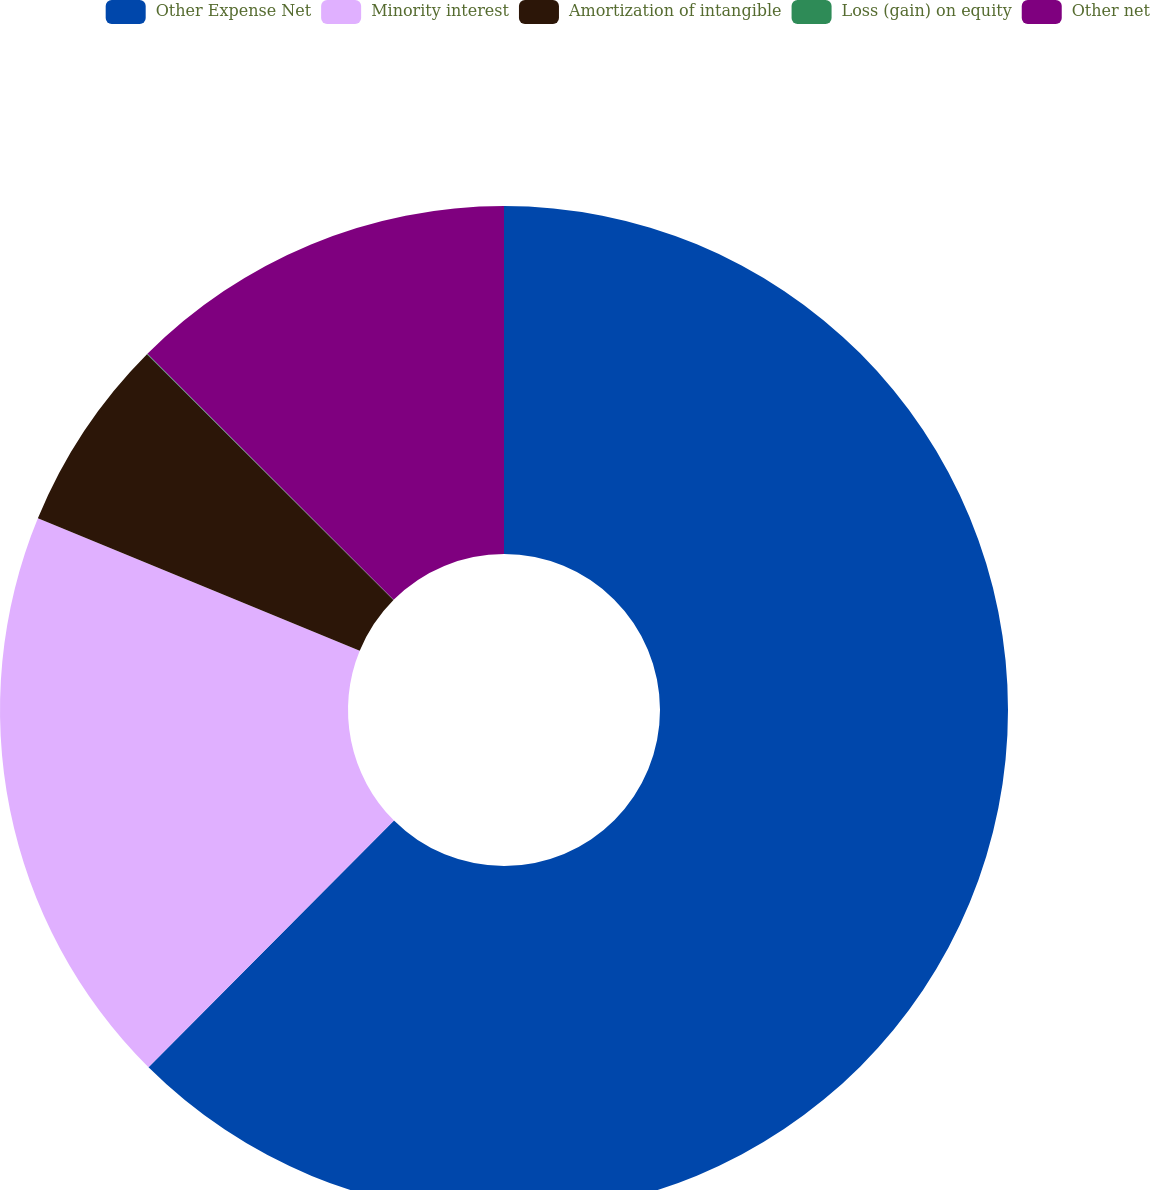<chart> <loc_0><loc_0><loc_500><loc_500><pie_chart><fcel>Other Expense Net<fcel>Minority interest<fcel>Amortization of intangible<fcel>Loss (gain) on equity<fcel>Other net<nl><fcel>62.46%<fcel>18.75%<fcel>6.26%<fcel>0.02%<fcel>12.51%<nl></chart> 